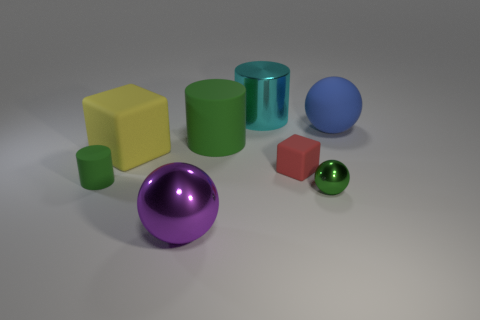What can you tell me about the sizes and shapes of the objects in the image? The image displays a variety of geometric shapes consisting of cubes, cylinders, and spheres. Their sizes range from small to large. For example, there are small and large cubes, a small and a large cylinder, along with smaller and larger spheres. What do the different finishes on the objects suggest about the materials they might be made of? The objects exhibit various finishes from matte to shiny, suggesting they could be made of different materials. Matte surfaces might indicate an object is made of plastic or rubber, whereas shiny, reflective surfaces could suggest a material like polished metal or glass. 